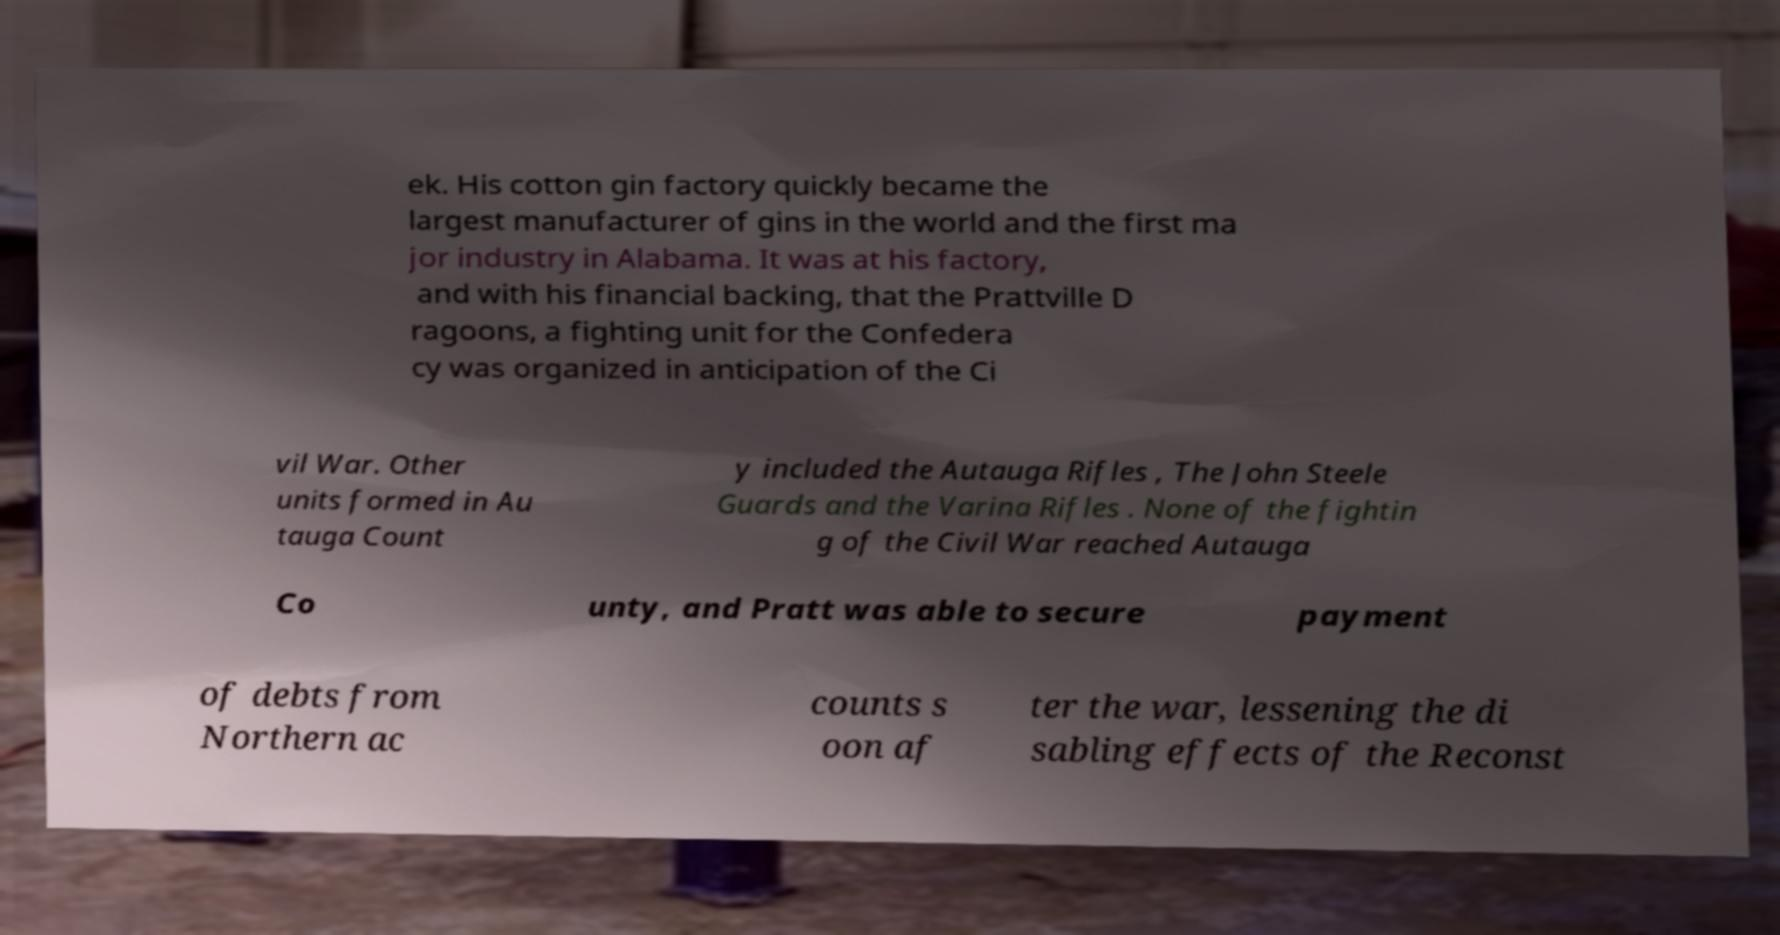Could you assist in decoding the text presented in this image and type it out clearly? ek. His cotton gin factory quickly became the largest manufacturer of gins in the world and the first ma jor industry in Alabama. It was at his factory, and with his financial backing, that the Prattville D ragoons, a fighting unit for the Confedera cy was organized in anticipation of the Ci vil War. Other units formed in Au tauga Count y included the Autauga Rifles , The John Steele Guards and the Varina Rifles . None of the fightin g of the Civil War reached Autauga Co unty, and Pratt was able to secure payment of debts from Northern ac counts s oon af ter the war, lessening the di sabling effects of the Reconst 